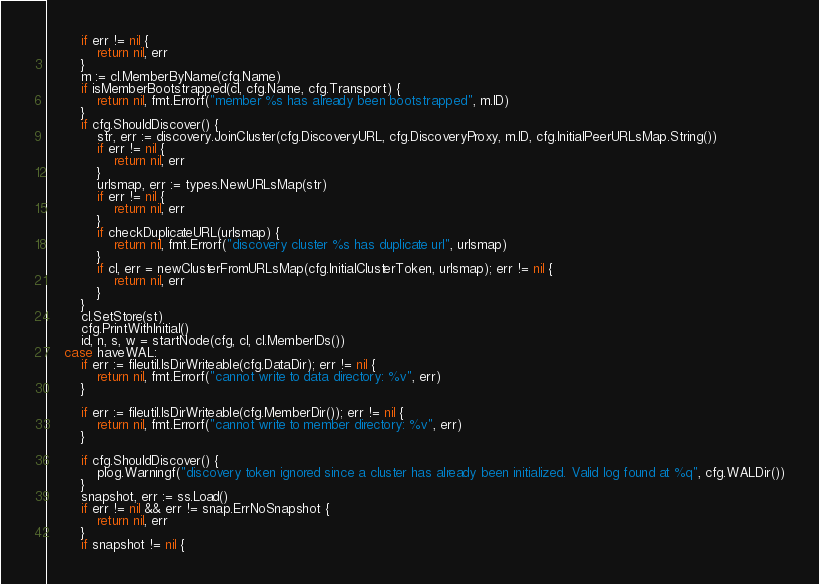Convert code to text. <code><loc_0><loc_0><loc_500><loc_500><_Go_>		if err != nil {
			return nil, err
		}
		m := cl.MemberByName(cfg.Name)
		if isMemberBootstrapped(cl, cfg.Name, cfg.Transport) {
			return nil, fmt.Errorf("member %s has already been bootstrapped", m.ID)
		}
		if cfg.ShouldDiscover() {
			str, err := discovery.JoinCluster(cfg.DiscoveryURL, cfg.DiscoveryProxy, m.ID, cfg.InitialPeerURLsMap.String())
			if err != nil {
				return nil, err
			}
			urlsmap, err := types.NewURLsMap(str)
			if err != nil {
				return nil, err
			}
			if checkDuplicateURL(urlsmap) {
				return nil, fmt.Errorf("discovery cluster %s has duplicate url", urlsmap)
			}
			if cl, err = newClusterFromURLsMap(cfg.InitialClusterToken, urlsmap); err != nil {
				return nil, err
			}
		}
		cl.SetStore(st)
		cfg.PrintWithInitial()
		id, n, s, w = startNode(cfg, cl, cl.MemberIDs())
	case haveWAL:
		if err := fileutil.IsDirWriteable(cfg.DataDir); err != nil {
			return nil, fmt.Errorf("cannot write to data directory: %v", err)
		}

		if err := fileutil.IsDirWriteable(cfg.MemberDir()); err != nil {
			return nil, fmt.Errorf("cannot write to member directory: %v", err)
		}

		if cfg.ShouldDiscover() {
			plog.Warningf("discovery token ignored since a cluster has already been initialized. Valid log found at %q", cfg.WALDir())
		}
		snapshot, err := ss.Load()
		if err != nil && err != snap.ErrNoSnapshot {
			return nil, err
		}
		if snapshot != nil {</code> 